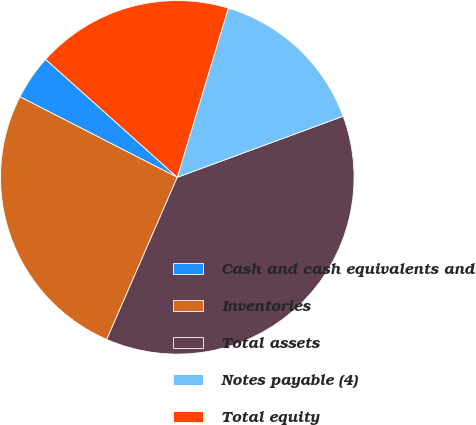Convert chart to OTSL. <chart><loc_0><loc_0><loc_500><loc_500><pie_chart><fcel>Cash and cash equivalents and<fcel>Inventories<fcel>Total assets<fcel>Notes payable (4)<fcel>Total equity<nl><fcel>4.1%<fcel>26.0%<fcel>37.15%<fcel>14.72%<fcel>18.03%<nl></chart> 